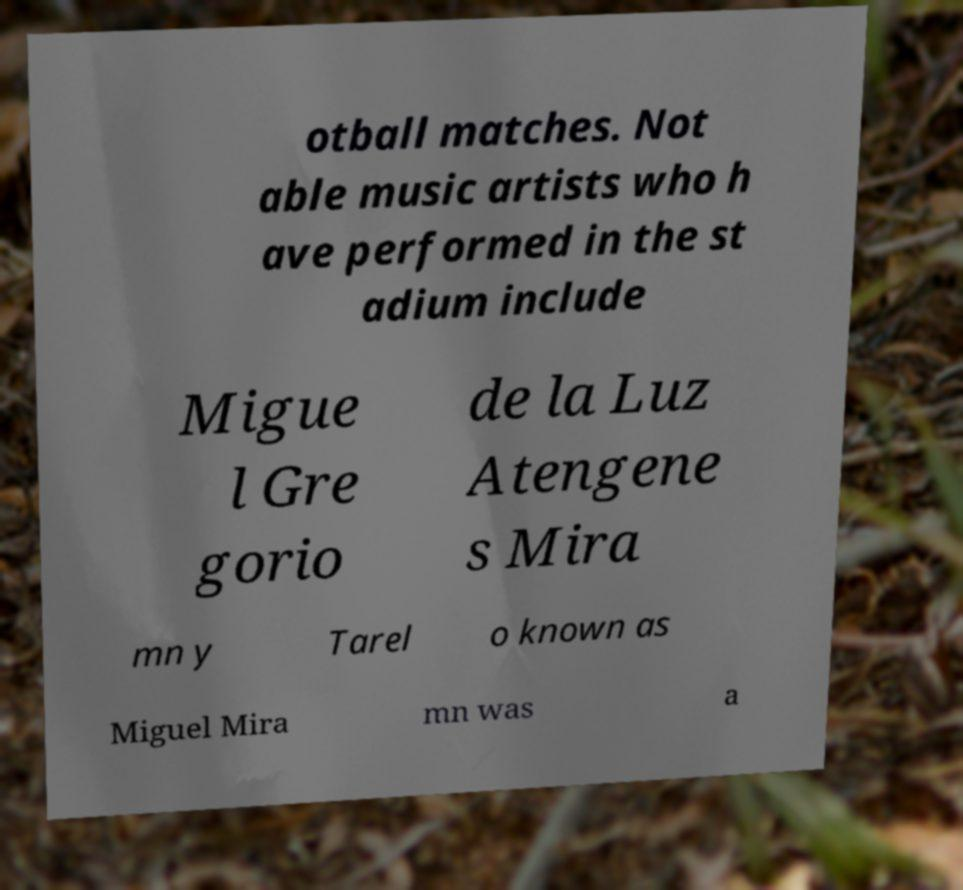Could you assist in decoding the text presented in this image and type it out clearly? otball matches. Not able music artists who h ave performed in the st adium include Migue l Gre gorio de la Luz Atengene s Mira mn y Tarel o known as Miguel Mira mn was a 